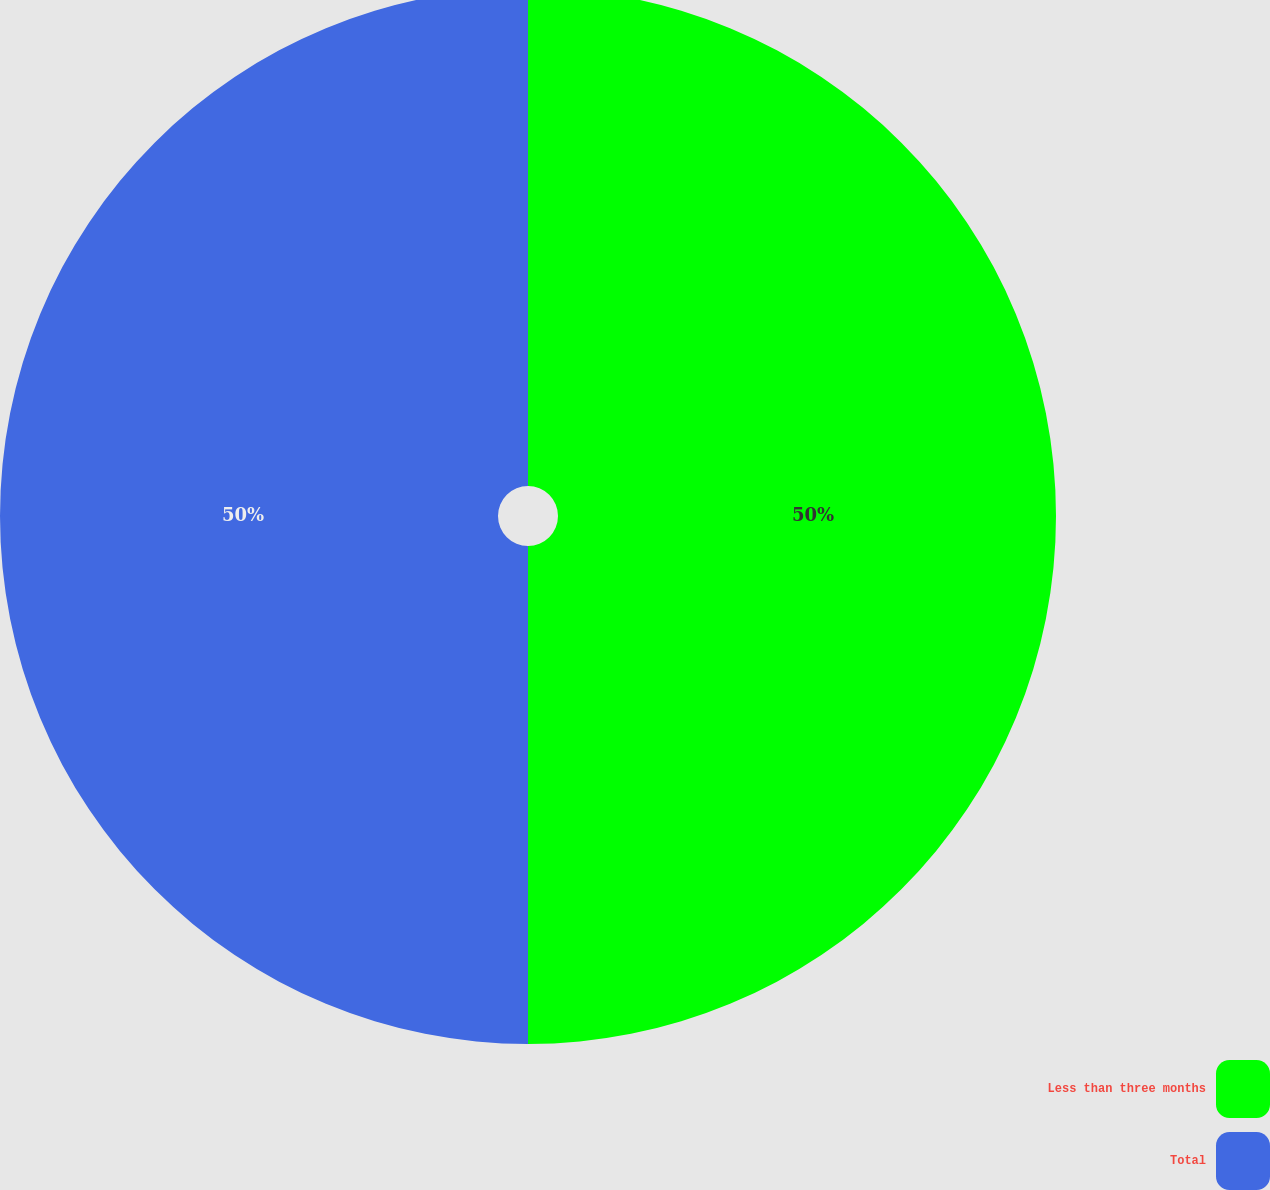Convert chart. <chart><loc_0><loc_0><loc_500><loc_500><pie_chart><fcel>Less than three months<fcel>Total<nl><fcel>50.0%<fcel>50.0%<nl></chart> 